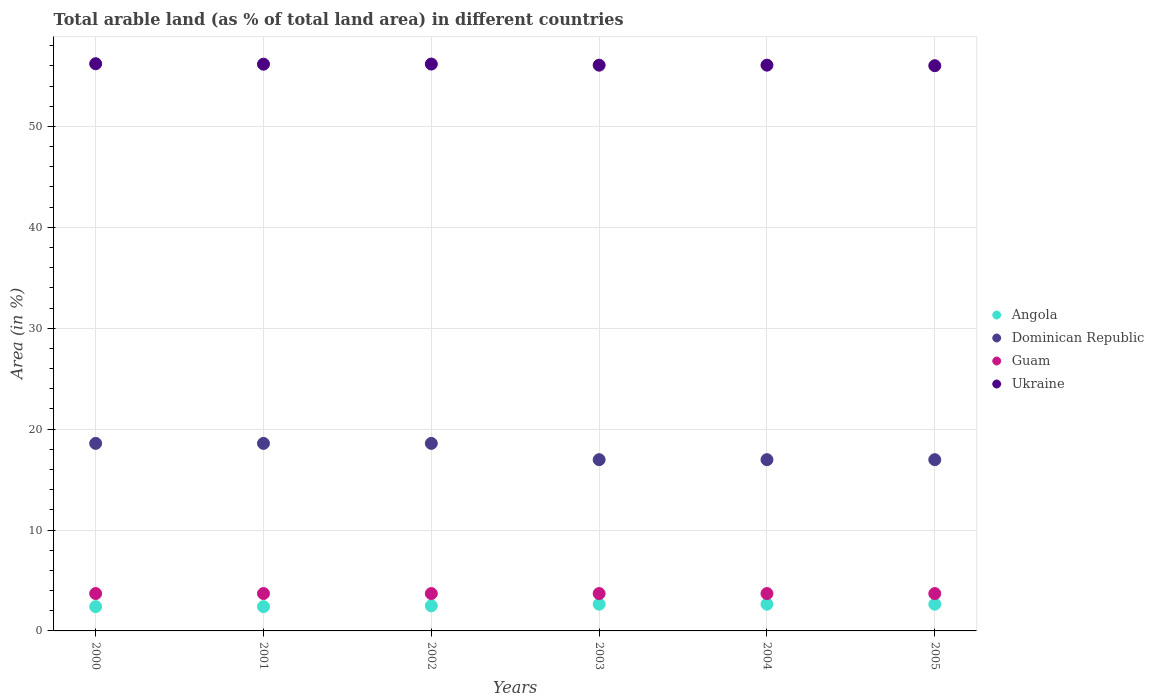How many different coloured dotlines are there?
Ensure brevity in your answer.  4. What is the percentage of arable land in Guam in 2001?
Your answer should be very brief. 3.7. Across all years, what is the maximum percentage of arable land in Dominican Republic?
Provide a succinct answer. 18.58. Across all years, what is the minimum percentage of arable land in Guam?
Ensure brevity in your answer.  3.7. In which year was the percentage of arable land in Guam minimum?
Provide a short and direct response. 2000. What is the total percentage of arable land in Angola in the graph?
Your answer should be very brief. 15.24. What is the difference between the percentage of arable land in Dominican Republic in 2004 and the percentage of arable land in Ukraine in 2001?
Offer a terse response. -39.19. What is the average percentage of arable land in Dominican Republic per year?
Provide a succinct answer. 17.78. In the year 2005, what is the difference between the percentage of arable land in Angola and percentage of arable land in Ukraine?
Your answer should be very brief. -53.36. In how many years, is the percentage of arable land in Ukraine greater than 2 %?
Make the answer very short. 6. What is the difference between the highest and the second highest percentage of arable land in Ukraine?
Ensure brevity in your answer.  0.03. What is the difference between the highest and the lowest percentage of arable land in Dominican Republic?
Offer a very short reply. 1.61. In how many years, is the percentage of arable land in Dominican Republic greater than the average percentage of arable land in Dominican Republic taken over all years?
Provide a short and direct response. 3. Is it the case that in every year, the sum of the percentage of arable land in Angola and percentage of arable land in Guam  is greater than the sum of percentage of arable land in Dominican Republic and percentage of arable land in Ukraine?
Keep it short and to the point. No. Does the percentage of arable land in Ukraine monotonically increase over the years?
Your answer should be very brief. No. Is the percentage of arable land in Guam strictly less than the percentage of arable land in Ukraine over the years?
Give a very brief answer. Yes. How many dotlines are there?
Ensure brevity in your answer.  4. What is the difference between two consecutive major ticks on the Y-axis?
Give a very brief answer. 10. Are the values on the major ticks of Y-axis written in scientific E-notation?
Your answer should be compact. No. Does the graph contain any zero values?
Offer a very short reply. No. Where does the legend appear in the graph?
Keep it short and to the point. Center right. What is the title of the graph?
Provide a short and direct response. Total arable land (as % of total land area) in different countries. Does "Croatia" appear as one of the legend labels in the graph?
Offer a terse response. No. What is the label or title of the Y-axis?
Keep it short and to the point. Area (in %). What is the Area (in %) of Angola in 2000?
Your answer should be compact. 2.41. What is the Area (in %) of Dominican Republic in 2000?
Give a very brief answer. 18.58. What is the Area (in %) of Guam in 2000?
Provide a short and direct response. 3.7. What is the Area (in %) in Ukraine in 2000?
Provide a short and direct response. 56.21. What is the Area (in %) of Angola in 2001?
Keep it short and to the point. 2.41. What is the Area (in %) in Dominican Republic in 2001?
Provide a short and direct response. 18.58. What is the Area (in %) of Guam in 2001?
Your answer should be compact. 3.7. What is the Area (in %) of Ukraine in 2001?
Provide a succinct answer. 56.16. What is the Area (in %) of Angola in 2002?
Offer a very short reply. 2.49. What is the Area (in %) in Dominican Republic in 2002?
Give a very brief answer. 18.58. What is the Area (in %) in Guam in 2002?
Your answer should be compact. 3.7. What is the Area (in %) in Ukraine in 2002?
Provide a short and direct response. 56.17. What is the Area (in %) in Angola in 2003?
Offer a terse response. 2.65. What is the Area (in %) in Dominican Republic in 2003?
Provide a succinct answer. 16.97. What is the Area (in %) in Guam in 2003?
Provide a succinct answer. 3.7. What is the Area (in %) in Ukraine in 2003?
Provide a succinct answer. 56.06. What is the Area (in %) in Angola in 2004?
Give a very brief answer. 2.65. What is the Area (in %) of Dominican Republic in 2004?
Give a very brief answer. 16.97. What is the Area (in %) in Guam in 2004?
Your answer should be very brief. 3.7. What is the Area (in %) of Ukraine in 2004?
Ensure brevity in your answer.  56.07. What is the Area (in %) in Angola in 2005?
Your answer should be very brief. 2.65. What is the Area (in %) in Dominican Republic in 2005?
Provide a short and direct response. 16.97. What is the Area (in %) of Guam in 2005?
Ensure brevity in your answer.  3.7. What is the Area (in %) of Ukraine in 2005?
Offer a terse response. 56.01. Across all years, what is the maximum Area (in %) of Angola?
Make the answer very short. 2.65. Across all years, what is the maximum Area (in %) in Dominican Republic?
Ensure brevity in your answer.  18.58. Across all years, what is the maximum Area (in %) in Guam?
Your answer should be compact. 3.7. Across all years, what is the maximum Area (in %) in Ukraine?
Provide a short and direct response. 56.21. Across all years, what is the minimum Area (in %) of Angola?
Your response must be concise. 2.41. Across all years, what is the minimum Area (in %) of Dominican Republic?
Ensure brevity in your answer.  16.97. Across all years, what is the minimum Area (in %) in Guam?
Your response must be concise. 3.7. Across all years, what is the minimum Area (in %) of Ukraine?
Make the answer very short. 56.01. What is the total Area (in %) of Angola in the graph?
Your answer should be compact. 15.24. What is the total Area (in %) of Dominican Republic in the graph?
Keep it short and to the point. 106.66. What is the total Area (in %) of Guam in the graph?
Provide a short and direct response. 22.22. What is the total Area (in %) in Ukraine in the graph?
Your answer should be compact. 336.69. What is the difference between the Area (in %) of Angola in 2000 and that in 2001?
Ensure brevity in your answer.  0. What is the difference between the Area (in %) in Ukraine in 2000 and that in 2001?
Your response must be concise. 0.05. What is the difference between the Area (in %) in Angola in 2000 and that in 2002?
Your answer should be very brief. -0.08. What is the difference between the Area (in %) in Guam in 2000 and that in 2002?
Your answer should be very brief. 0. What is the difference between the Area (in %) of Ukraine in 2000 and that in 2002?
Your answer should be very brief. 0.03. What is the difference between the Area (in %) in Angola in 2000 and that in 2003?
Make the answer very short. -0.24. What is the difference between the Area (in %) in Dominican Republic in 2000 and that in 2003?
Keep it short and to the point. 1.61. What is the difference between the Area (in %) of Guam in 2000 and that in 2003?
Give a very brief answer. 0. What is the difference between the Area (in %) in Ukraine in 2000 and that in 2003?
Provide a succinct answer. 0.14. What is the difference between the Area (in %) in Angola in 2000 and that in 2004?
Give a very brief answer. -0.24. What is the difference between the Area (in %) of Dominican Republic in 2000 and that in 2004?
Give a very brief answer. 1.61. What is the difference between the Area (in %) in Guam in 2000 and that in 2004?
Give a very brief answer. 0. What is the difference between the Area (in %) of Ukraine in 2000 and that in 2004?
Make the answer very short. 0.14. What is the difference between the Area (in %) in Angola in 2000 and that in 2005?
Give a very brief answer. -0.24. What is the difference between the Area (in %) of Dominican Republic in 2000 and that in 2005?
Provide a short and direct response. 1.61. What is the difference between the Area (in %) of Ukraine in 2000 and that in 2005?
Make the answer very short. 0.2. What is the difference between the Area (in %) of Angola in 2001 and that in 2002?
Ensure brevity in your answer.  -0.08. What is the difference between the Area (in %) of Ukraine in 2001 and that in 2002?
Offer a very short reply. -0.01. What is the difference between the Area (in %) of Angola in 2001 and that in 2003?
Ensure brevity in your answer.  -0.24. What is the difference between the Area (in %) of Dominican Republic in 2001 and that in 2003?
Make the answer very short. 1.61. What is the difference between the Area (in %) in Ukraine in 2001 and that in 2003?
Keep it short and to the point. 0.1. What is the difference between the Area (in %) of Angola in 2001 and that in 2004?
Offer a terse response. -0.24. What is the difference between the Area (in %) of Dominican Republic in 2001 and that in 2004?
Your answer should be compact. 1.61. What is the difference between the Area (in %) in Ukraine in 2001 and that in 2004?
Provide a succinct answer. 0.09. What is the difference between the Area (in %) in Angola in 2001 and that in 2005?
Your answer should be very brief. -0.24. What is the difference between the Area (in %) in Dominican Republic in 2001 and that in 2005?
Offer a very short reply. 1.61. What is the difference between the Area (in %) in Guam in 2001 and that in 2005?
Your answer should be compact. 0. What is the difference between the Area (in %) in Ukraine in 2001 and that in 2005?
Your answer should be very brief. 0.15. What is the difference between the Area (in %) of Angola in 2002 and that in 2003?
Offer a terse response. -0.16. What is the difference between the Area (in %) of Dominican Republic in 2002 and that in 2003?
Provide a short and direct response. 1.61. What is the difference between the Area (in %) of Ukraine in 2002 and that in 2003?
Make the answer very short. 0.11. What is the difference between the Area (in %) in Angola in 2002 and that in 2004?
Your answer should be compact. -0.16. What is the difference between the Area (in %) in Dominican Republic in 2002 and that in 2004?
Offer a very short reply. 1.61. What is the difference between the Area (in %) of Guam in 2002 and that in 2004?
Your answer should be compact. 0. What is the difference between the Area (in %) of Ukraine in 2002 and that in 2004?
Offer a very short reply. 0.11. What is the difference between the Area (in %) in Angola in 2002 and that in 2005?
Offer a terse response. -0.16. What is the difference between the Area (in %) in Dominican Republic in 2002 and that in 2005?
Ensure brevity in your answer.  1.61. What is the difference between the Area (in %) of Ukraine in 2002 and that in 2005?
Offer a terse response. 0.16. What is the difference between the Area (in %) of Angola in 2003 and that in 2004?
Keep it short and to the point. 0. What is the difference between the Area (in %) in Dominican Republic in 2003 and that in 2004?
Keep it short and to the point. 0. What is the difference between the Area (in %) in Guam in 2003 and that in 2004?
Offer a terse response. 0. What is the difference between the Area (in %) in Ukraine in 2003 and that in 2004?
Your response must be concise. -0. What is the difference between the Area (in %) of Angola in 2003 and that in 2005?
Offer a very short reply. 0. What is the difference between the Area (in %) of Dominican Republic in 2003 and that in 2005?
Make the answer very short. 0. What is the difference between the Area (in %) in Guam in 2003 and that in 2005?
Keep it short and to the point. 0. What is the difference between the Area (in %) of Ukraine in 2003 and that in 2005?
Keep it short and to the point. 0.05. What is the difference between the Area (in %) of Angola in 2004 and that in 2005?
Offer a very short reply. 0. What is the difference between the Area (in %) of Ukraine in 2004 and that in 2005?
Give a very brief answer. 0.06. What is the difference between the Area (in %) in Angola in 2000 and the Area (in %) in Dominican Republic in 2001?
Keep it short and to the point. -16.18. What is the difference between the Area (in %) in Angola in 2000 and the Area (in %) in Guam in 2001?
Provide a succinct answer. -1.3. What is the difference between the Area (in %) of Angola in 2000 and the Area (in %) of Ukraine in 2001?
Provide a succinct answer. -53.75. What is the difference between the Area (in %) of Dominican Republic in 2000 and the Area (in %) of Guam in 2001?
Provide a succinct answer. 14.88. What is the difference between the Area (in %) in Dominican Republic in 2000 and the Area (in %) in Ukraine in 2001?
Keep it short and to the point. -37.58. What is the difference between the Area (in %) in Guam in 2000 and the Area (in %) in Ukraine in 2001?
Keep it short and to the point. -52.46. What is the difference between the Area (in %) of Angola in 2000 and the Area (in %) of Dominican Republic in 2002?
Give a very brief answer. -16.18. What is the difference between the Area (in %) of Angola in 2000 and the Area (in %) of Guam in 2002?
Offer a very short reply. -1.3. What is the difference between the Area (in %) of Angola in 2000 and the Area (in %) of Ukraine in 2002?
Make the answer very short. -53.77. What is the difference between the Area (in %) of Dominican Republic in 2000 and the Area (in %) of Guam in 2002?
Your answer should be compact. 14.88. What is the difference between the Area (in %) of Dominican Republic in 2000 and the Area (in %) of Ukraine in 2002?
Make the answer very short. -37.59. What is the difference between the Area (in %) in Guam in 2000 and the Area (in %) in Ukraine in 2002?
Provide a succinct answer. -52.47. What is the difference between the Area (in %) of Angola in 2000 and the Area (in %) of Dominican Republic in 2003?
Give a very brief answer. -14.56. What is the difference between the Area (in %) of Angola in 2000 and the Area (in %) of Guam in 2003?
Your response must be concise. -1.3. What is the difference between the Area (in %) of Angola in 2000 and the Area (in %) of Ukraine in 2003?
Make the answer very short. -53.66. What is the difference between the Area (in %) in Dominican Republic in 2000 and the Area (in %) in Guam in 2003?
Give a very brief answer. 14.88. What is the difference between the Area (in %) in Dominican Republic in 2000 and the Area (in %) in Ukraine in 2003?
Provide a succinct answer. -37.48. What is the difference between the Area (in %) in Guam in 2000 and the Area (in %) in Ukraine in 2003?
Your response must be concise. -52.36. What is the difference between the Area (in %) in Angola in 2000 and the Area (in %) in Dominican Republic in 2004?
Provide a succinct answer. -14.56. What is the difference between the Area (in %) in Angola in 2000 and the Area (in %) in Guam in 2004?
Your response must be concise. -1.3. What is the difference between the Area (in %) of Angola in 2000 and the Area (in %) of Ukraine in 2004?
Offer a very short reply. -53.66. What is the difference between the Area (in %) in Dominican Republic in 2000 and the Area (in %) in Guam in 2004?
Keep it short and to the point. 14.88. What is the difference between the Area (in %) of Dominican Republic in 2000 and the Area (in %) of Ukraine in 2004?
Make the answer very short. -37.48. What is the difference between the Area (in %) of Guam in 2000 and the Area (in %) of Ukraine in 2004?
Keep it short and to the point. -52.36. What is the difference between the Area (in %) in Angola in 2000 and the Area (in %) in Dominican Republic in 2005?
Offer a terse response. -14.56. What is the difference between the Area (in %) of Angola in 2000 and the Area (in %) of Guam in 2005?
Your response must be concise. -1.3. What is the difference between the Area (in %) in Angola in 2000 and the Area (in %) in Ukraine in 2005?
Your answer should be compact. -53.61. What is the difference between the Area (in %) of Dominican Republic in 2000 and the Area (in %) of Guam in 2005?
Offer a very short reply. 14.88. What is the difference between the Area (in %) in Dominican Republic in 2000 and the Area (in %) in Ukraine in 2005?
Give a very brief answer. -37.43. What is the difference between the Area (in %) of Guam in 2000 and the Area (in %) of Ukraine in 2005?
Offer a very short reply. -52.31. What is the difference between the Area (in %) in Angola in 2001 and the Area (in %) in Dominican Republic in 2002?
Offer a very short reply. -16.18. What is the difference between the Area (in %) of Angola in 2001 and the Area (in %) of Guam in 2002?
Your response must be concise. -1.3. What is the difference between the Area (in %) of Angola in 2001 and the Area (in %) of Ukraine in 2002?
Offer a very short reply. -53.77. What is the difference between the Area (in %) in Dominican Republic in 2001 and the Area (in %) in Guam in 2002?
Provide a short and direct response. 14.88. What is the difference between the Area (in %) of Dominican Republic in 2001 and the Area (in %) of Ukraine in 2002?
Provide a succinct answer. -37.59. What is the difference between the Area (in %) in Guam in 2001 and the Area (in %) in Ukraine in 2002?
Provide a succinct answer. -52.47. What is the difference between the Area (in %) in Angola in 2001 and the Area (in %) in Dominican Republic in 2003?
Provide a short and direct response. -14.56. What is the difference between the Area (in %) in Angola in 2001 and the Area (in %) in Guam in 2003?
Ensure brevity in your answer.  -1.3. What is the difference between the Area (in %) in Angola in 2001 and the Area (in %) in Ukraine in 2003?
Offer a very short reply. -53.66. What is the difference between the Area (in %) in Dominican Republic in 2001 and the Area (in %) in Guam in 2003?
Ensure brevity in your answer.  14.88. What is the difference between the Area (in %) of Dominican Republic in 2001 and the Area (in %) of Ukraine in 2003?
Your answer should be compact. -37.48. What is the difference between the Area (in %) of Guam in 2001 and the Area (in %) of Ukraine in 2003?
Provide a short and direct response. -52.36. What is the difference between the Area (in %) in Angola in 2001 and the Area (in %) in Dominican Republic in 2004?
Your answer should be compact. -14.56. What is the difference between the Area (in %) of Angola in 2001 and the Area (in %) of Guam in 2004?
Ensure brevity in your answer.  -1.3. What is the difference between the Area (in %) in Angola in 2001 and the Area (in %) in Ukraine in 2004?
Your response must be concise. -53.66. What is the difference between the Area (in %) in Dominican Republic in 2001 and the Area (in %) in Guam in 2004?
Provide a succinct answer. 14.88. What is the difference between the Area (in %) of Dominican Republic in 2001 and the Area (in %) of Ukraine in 2004?
Provide a succinct answer. -37.48. What is the difference between the Area (in %) in Guam in 2001 and the Area (in %) in Ukraine in 2004?
Give a very brief answer. -52.36. What is the difference between the Area (in %) in Angola in 2001 and the Area (in %) in Dominican Republic in 2005?
Ensure brevity in your answer.  -14.56. What is the difference between the Area (in %) in Angola in 2001 and the Area (in %) in Guam in 2005?
Provide a succinct answer. -1.3. What is the difference between the Area (in %) of Angola in 2001 and the Area (in %) of Ukraine in 2005?
Your answer should be compact. -53.61. What is the difference between the Area (in %) of Dominican Republic in 2001 and the Area (in %) of Guam in 2005?
Ensure brevity in your answer.  14.88. What is the difference between the Area (in %) of Dominican Republic in 2001 and the Area (in %) of Ukraine in 2005?
Offer a terse response. -37.43. What is the difference between the Area (in %) in Guam in 2001 and the Area (in %) in Ukraine in 2005?
Offer a terse response. -52.31. What is the difference between the Area (in %) of Angola in 2002 and the Area (in %) of Dominican Republic in 2003?
Make the answer very short. -14.48. What is the difference between the Area (in %) of Angola in 2002 and the Area (in %) of Guam in 2003?
Your response must be concise. -1.22. What is the difference between the Area (in %) in Angola in 2002 and the Area (in %) in Ukraine in 2003?
Your answer should be very brief. -53.58. What is the difference between the Area (in %) of Dominican Republic in 2002 and the Area (in %) of Guam in 2003?
Your response must be concise. 14.88. What is the difference between the Area (in %) in Dominican Republic in 2002 and the Area (in %) in Ukraine in 2003?
Your answer should be compact. -37.48. What is the difference between the Area (in %) in Guam in 2002 and the Area (in %) in Ukraine in 2003?
Your response must be concise. -52.36. What is the difference between the Area (in %) of Angola in 2002 and the Area (in %) of Dominican Republic in 2004?
Provide a succinct answer. -14.48. What is the difference between the Area (in %) of Angola in 2002 and the Area (in %) of Guam in 2004?
Make the answer very short. -1.22. What is the difference between the Area (in %) of Angola in 2002 and the Area (in %) of Ukraine in 2004?
Ensure brevity in your answer.  -53.58. What is the difference between the Area (in %) of Dominican Republic in 2002 and the Area (in %) of Guam in 2004?
Ensure brevity in your answer.  14.88. What is the difference between the Area (in %) of Dominican Republic in 2002 and the Area (in %) of Ukraine in 2004?
Make the answer very short. -37.48. What is the difference between the Area (in %) of Guam in 2002 and the Area (in %) of Ukraine in 2004?
Your answer should be compact. -52.36. What is the difference between the Area (in %) of Angola in 2002 and the Area (in %) of Dominican Republic in 2005?
Offer a very short reply. -14.48. What is the difference between the Area (in %) in Angola in 2002 and the Area (in %) in Guam in 2005?
Your answer should be compact. -1.22. What is the difference between the Area (in %) of Angola in 2002 and the Area (in %) of Ukraine in 2005?
Ensure brevity in your answer.  -53.52. What is the difference between the Area (in %) of Dominican Republic in 2002 and the Area (in %) of Guam in 2005?
Make the answer very short. 14.88. What is the difference between the Area (in %) in Dominican Republic in 2002 and the Area (in %) in Ukraine in 2005?
Make the answer very short. -37.43. What is the difference between the Area (in %) of Guam in 2002 and the Area (in %) of Ukraine in 2005?
Offer a terse response. -52.31. What is the difference between the Area (in %) of Angola in 2003 and the Area (in %) of Dominican Republic in 2004?
Your answer should be very brief. -14.32. What is the difference between the Area (in %) in Angola in 2003 and the Area (in %) in Guam in 2004?
Ensure brevity in your answer.  -1.06. What is the difference between the Area (in %) of Angola in 2003 and the Area (in %) of Ukraine in 2004?
Provide a short and direct response. -53.42. What is the difference between the Area (in %) in Dominican Republic in 2003 and the Area (in %) in Guam in 2004?
Offer a very short reply. 13.27. What is the difference between the Area (in %) in Dominican Republic in 2003 and the Area (in %) in Ukraine in 2004?
Provide a succinct answer. -39.1. What is the difference between the Area (in %) of Guam in 2003 and the Area (in %) of Ukraine in 2004?
Your response must be concise. -52.36. What is the difference between the Area (in %) of Angola in 2003 and the Area (in %) of Dominican Republic in 2005?
Give a very brief answer. -14.32. What is the difference between the Area (in %) of Angola in 2003 and the Area (in %) of Guam in 2005?
Provide a short and direct response. -1.06. What is the difference between the Area (in %) in Angola in 2003 and the Area (in %) in Ukraine in 2005?
Offer a terse response. -53.36. What is the difference between the Area (in %) in Dominican Republic in 2003 and the Area (in %) in Guam in 2005?
Make the answer very short. 13.27. What is the difference between the Area (in %) in Dominican Republic in 2003 and the Area (in %) in Ukraine in 2005?
Give a very brief answer. -39.04. What is the difference between the Area (in %) in Guam in 2003 and the Area (in %) in Ukraine in 2005?
Your answer should be very brief. -52.31. What is the difference between the Area (in %) of Angola in 2004 and the Area (in %) of Dominican Republic in 2005?
Offer a very short reply. -14.32. What is the difference between the Area (in %) of Angola in 2004 and the Area (in %) of Guam in 2005?
Give a very brief answer. -1.06. What is the difference between the Area (in %) in Angola in 2004 and the Area (in %) in Ukraine in 2005?
Your answer should be very brief. -53.36. What is the difference between the Area (in %) in Dominican Republic in 2004 and the Area (in %) in Guam in 2005?
Provide a short and direct response. 13.27. What is the difference between the Area (in %) in Dominican Republic in 2004 and the Area (in %) in Ukraine in 2005?
Give a very brief answer. -39.04. What is the difference between the Area (in %) of Guam in 2004 and the Area (in %) of Ukraine in 2005?
Your response must be concise. -52.31. What is the average Area (in %) in Angola per year?
Keep it short and to the point. 2.54. What is the average Area (in %) of Dominican Republic per year?
Your answer should be compact. 17.78. What is the average Area (in %) of Guam per year?
Offer a terse response. 3.7. What is the average Area (in %) of Ukraine per year?
Offer a very short reply. 56.11. In the year 2000, what is the difference between the Area (in %) in Angola and Area (in %) in Dominican Republic?
Your response must be concise. -16.18. In the year 2000, what is the difference between the Area (in %) in Angola and Area (in %) in Guam?
Make the answer very short. -1.3. In the year 2000, what is the difference between the Area (in %) of Angola and Area (in %) of Ukraine?
Ensure brevity in your answer.  -53.8. In the year 2000, what is the difference between the Area (in %) in Dominican Republic and Area (in %) in Guam?
Your response must be concise. 14.88. In the year 2000, what is the difference between the Area (in %) of Dominican Republic and Area (in %) of Ukraine?
Provide a short and direct response. -37.62. In the year 2000, what is the difference between the Area (in %) in Guam and Area (in %) in Ukraine?
Give a very brief answer. -52.5. In the year 2001, what is the difference between the Area (in %) of Angola and Area (in %) of Dominican Republic?
Your answer should be very brief. -16.18. In the year 2001, what is the difference between the Area (in %) in Angola and Area (in %) in Guam?
Make the answer very short. -1.3. In the year 2001, what is the difference between the Area (in %) of Angola and Area (in %) of Ukraine?
Make the answer very short. -53.75. In the year 2001, what is the difference between the Area (in %) in Dominican Republic and Area (in %) in Guam?
Give a very brief answer. 14.88. In the year 2001, what is the difference between the Area (in %) in Dominican Republic and Area (in %) in Ukraine?
Your answer should be very brief. -37.58. In the year 2001, what is the difference between the Area (in %) in Guam and Area (in %) in Ukraine?
Give a very brief answer. -52.46. In the year 2002, what is the difference between the Area (in %) in Angola and Area (in %) in Dominican Republic?
Make the answer very short. -16.1. In the year 2002, what is the difference between the Area (in %) in Angola and Area (in %) in Guam?
Keep it short and to the point. -1.22. In the year 2002, what is the difference between the Area (in %) of Angola and Area (in %) of Ukraine?
Provide a succinct answer. -53.69. In the year 2002, what is the difference between the Area (in %) in Dominican Republic and Area (in %) in Guam?
Make the answer very short. 14.88. In the year 2002, what is the difference between the Area (in %) in Dominican Republic and Area (in %) in Ukraine?
Your answer should be very brief. -37.59. In the year 2002, what is the difference between the Area (in %) of Guam and Area (in %) of Ukraine?
Provide a succinct answer. -52.47. In the year 2003, what is the difference between the Area (in %) in Angola and Area (in %) in Dominican Republic?
Give a very brief answer. -14.32. In the year 2003, what is the difference between the Area (in %) in Angola and Area (in %) in Guam?
Your answer should be very brief. -1.06. In the year 2003, what is the difference between the Area (in %) of Angola and Area (in %) of Ukraine?
Provide a succinct answer. -53.42. In the year 2003, what is the difference between the Area (in %) in Dominican Republic and Area (in %) in Guam?
Offer a terse response. 13.27. In the year 2003, what is the difference between the Area (in %) in Dominican Republic and Area (in %) in Ukraine?
Provide a succinct answer. -39.09. In the year 2003, what is the difference between the Area (in %) in Guam and Area (in %) in Ukraine?
Your answer should be compact. -52.36. In the year 2004, what is the difference between the Area (in %) in Angola and Area (in %) in Dominican Republic?
Your answer should be very brief. -14.32. In the year 2004, what is the difference between the Area (in %) of Angola and Area (in %) of Guam?
Provide a short and direct response. -1.06. In the year 2004, what is the difference between the Area (in %) in Angola and Area (in %) in Ukraine?
Offer a very short reply. -53.42. In the year 2004, what is the difference between the Area (in %) in Dominican Republic and Area (in %) in Guam?
Your response must be concise. 13.27. In the year 2004, what is the difference between the Area (in %) in Dominican Republic and Area (in %) in Ukraine?
Make the answer very short. -39.1. In the year 2004, what is the difference between the Area (in %) of Guam and Area (in %) of Ukraine?
Your response must be concise. -52.36. In the year 2005, what is the difference between the Area (in %) of Angola and Area (in %) of Dominican Republic?
Keep it short and to the point. -14.32. In the year 2005, what is the difference between the Area (in %) in Angola and Area (in %) in Guam?
Provide a short and direct response. -1.06. In the year 2005, what is the difference between the Area (in %) in Angola and Area (in %) in Ukraine?
Provide a succinct answer. -53.36. In the year 2005, what is the difference between the Area (in %) of Dominican Republic and Area (in %) of Guam?
Offer a terse response. 13.27. In the year 2005, what is the difference between the Area (in %) of Dominican Republic and Area (in %) of Ukraine?
Your response must be concise. -39.04. In the year 2005, what is the difference between the Area (in %) of Guam and Area (in %) of Ukraine?
Your answer should be compact. -52.31. What is the ratio of the Area (in %) in Ukraine in 2000 to that in 2001?
Your answer should be very brief. 1. What is the ratio of the Area (in %) in Angola in 2000 to that in 2002?
Ensure brevity in your answer.  0.97. What is the ratio of the Area (in %) of Guam in 2000 to that in 2002?
Provide a short and direct response. 1. What is the ratio of the Area (in %) in Dominican Republic in 2000 to that in 2003?
Offer a terse response. 1.1. What is the ratio of the Area (in %) in Guam in 2000 to that in 2003?
Ensure brevity in your answer.  1. What is the ratio of the Area (in %) in Angola in 2000 to that in 2004?
Your answer should be compact. 0.91. What is the ratio of the Area (in %) of Dominican Republic in 2000 to that in 2004?
Provide a short and direct response. 1.1. What is the ratio of the Area (in %) of Guam in 2000 to that in 2004?
Provide a succinct answer. 1. What is the ratio of the Area (in %) of Ukraine in 2000 to that in 2004?
Make the answer very short. 1. What is the ratio of the Area (in %) of Dominican Republic in 2000 to that in 2005?
Provide a short and direct response. 1.1. What is the ratio of the Area (in %) of Ukraine in 2000 to that in 2005?
Your answer should be very brief. 1. What is the ratio of the Area (in %) in Angola in 2001 to that in 2002?
Ensure brevity in your answer.  0.97. What is the ratio of the Area (in %) of Angola in 2001 to that in 2003?
Ensure brevity in your answer.  0.91. What is the ratio of the Area (in %) in Dominican Republic in 2001 to that in 2003?
Provide a short and direct response. 1.1. What is the ratio of the Area (in %) of Dominican Republic in 2001 to that in 2004?
Your response must be concise. 1.1. What is the ratio of the Area (in %) of Guam in 2001 to that in 2004?
Make the answer very short. 1. What is the ratio of the Area (in %) of Ukraine in 2001 to that in 2004?
Your answer should be compact. 1. What is the ratio of the Area (in %) of Angola in 2001 to that in 2005?
Ensure brevity in your answer.  0.91. What is the ratio of the Area (in %) in Dominican Republic in 2001 to that in 2005?
Give a very brief answer. 1.1. What is the ratio of the Area (in %) in Guam in 2001 to that in 2005?
Ensure brevity in your answer.  1. What is the ratio of the Area (in %) of Ukraine in 2001 to that in 2005?
Provide a short and direct response. 1. What is the ratio of the Area (in %) in Angola in 2002 to that in 2003?
Offer a very short reply. 0.94. What is the ratio of the Area (in %) of Dominican Republic in 2002 to that in 2003?
Keep it short and to the point. 1.1. What is the ratio of the Area (in %) in Angola in 2002 to that in 2004?
Offer a terse response. 0.94. What is the ratio of the Area (in %) of Dominican Republic in 2002 to that in 2004?
Provide a short and direct response. 1.1. What is the ratio of the Area (in %) in Angola in 2002 to that in 2005?
Provide a succinct answer. 0.94. What is the ratio of the Area (in %) of Dominican Republic in 2002 to that in 2005?
Give a very brief answer. 1.1. What is the ratio of the Area (in %) of Dominican Republic in 2003 to that in 2004?
Make the answer very short. 1. What is the ratio of the Area (in %) of Guam in 2003 to that in 2004?
Ensure brevity in your answer.  1. What is the ratio of the Area (in %) in Angola in 2003 to that in 2005?
Make the answer very short. 1. What is the ratio of the Area (in %) of Guam in 2004 to that in 2005?
Keep it short and to the point. 1. What is the ratio of the Area (in %) in Ukraine in 2004 to that in 2005?
Make the answer very short. 1. What is the difference between the highest and the second highest Area (in %) of Angola?
Keep it short and to the point. 0. What is the difference between the highest and the second highest Area (in %) of Dominican Republic?
Give a very brief answer. 0. What is the difference between the highest and the second highest Area (in %) in Ukraine?
Your answer should be very brief. 0.03. What is the difference between the highest and the lowest Area (in %) in Angola?
Your response must be concise. 0.24. What is the difference between the highest and the lowest Area (in %) of Dominican Republic?
Give a very brief answer. 1.61. What is the difference between the highest and the lowest Area (in %) of Guam?
Offer a terse response. 0. What is the difference between the highest and the lowest Area (in %) of Ukraine?
Ensure brevity in your answer.  0.2. 